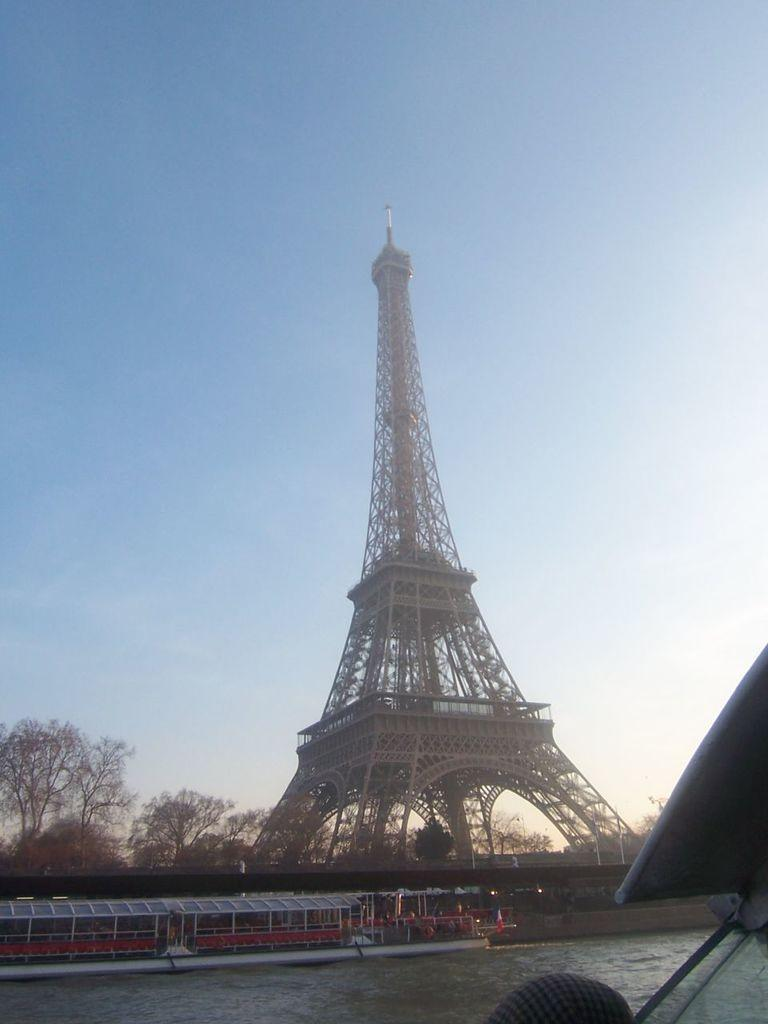What famous landmark can be seen in the image? There is an Eiffel tower in the image. What natural element is visible in the image? There is water visible in the image. What type of vegetation is present in the image? There are trees in the image. What is visible at the top of the image? The sky is visible at the top of the image. What type of pencil can be seen in the image? There is no pencil present in the image. Is there a fire visible in the image? There is no fire visible in the image. 